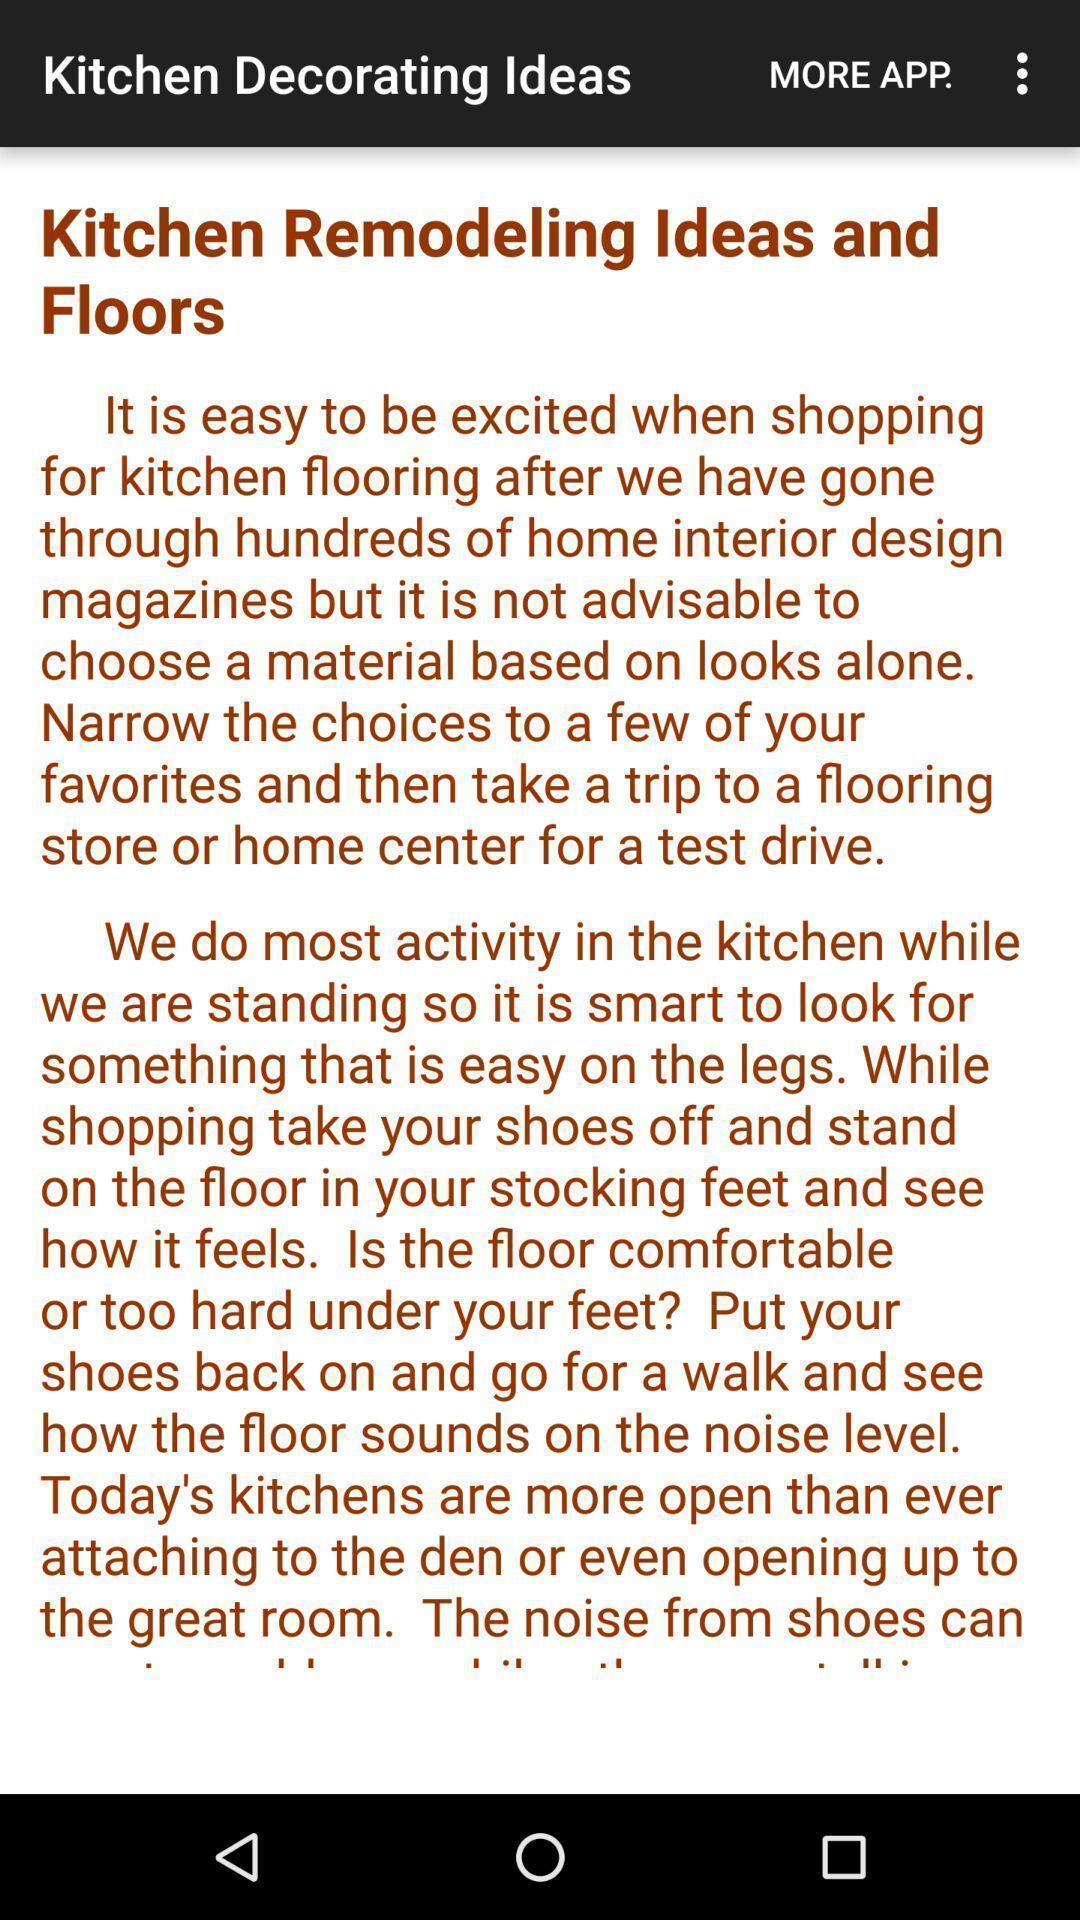Explain what's happening in this screen capture. Screen showing ideas. 